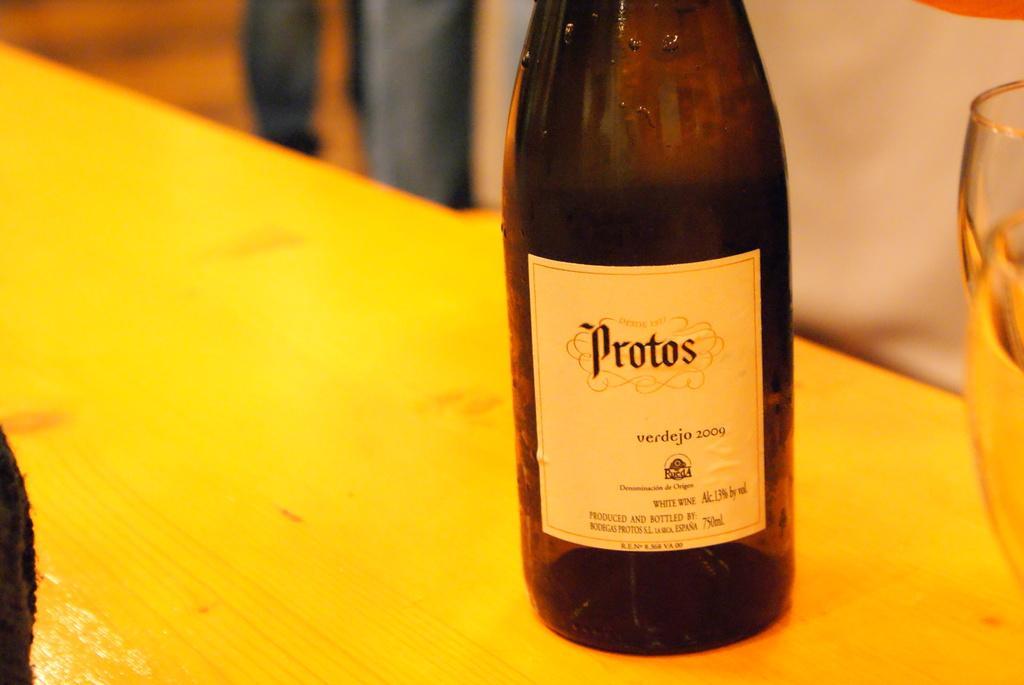Can you describe this image briefly? This bottle is highlighted in this picture and kept on a table, on this bottle there is a sticker. Background is blurry. Beside this bottle there are glasses. 